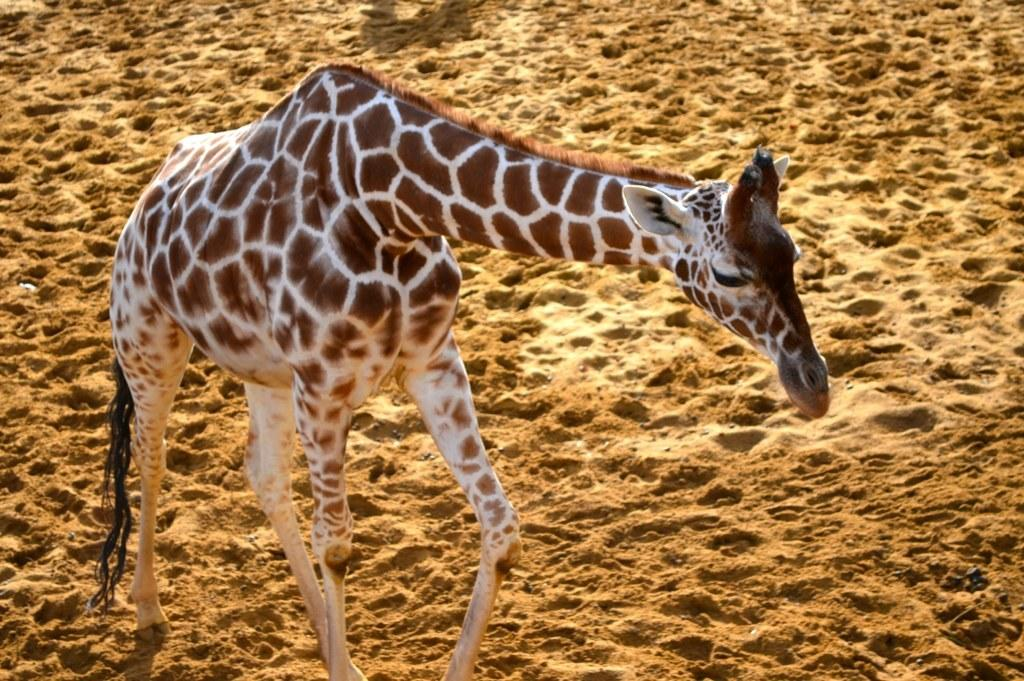What type of terrain is depicted in the image? There is sand in the image, suggesting a desert or beach setting. What animal can be seen in the image? There is a giraffe in the image. What type of street is visible in the image? There is no street present in the image; it features sand and a giraffe. How does the pump function in the image? There is no pump present in the image. 